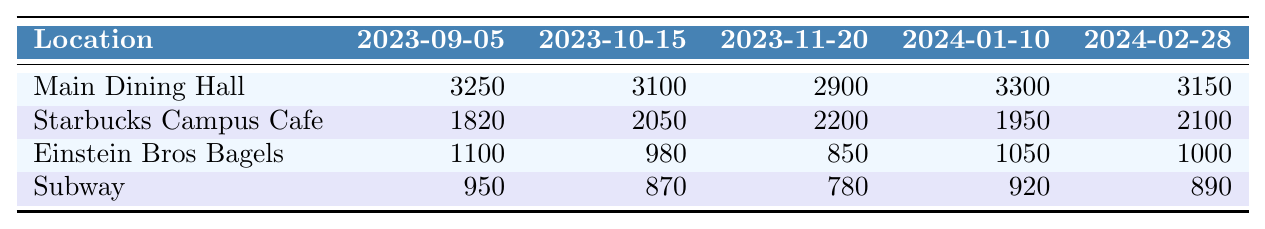What was the foot traffic for Starbucks Campus Cafe on 2023-11-20? The table shows that the foot traffic for Starbucks Campus Cafe on that date is clearly stated as 2200.
Answer: 2200 Which location had the highest foot traffic on 2024-01-10? The values for each location on that date are compared: Main Dining Hall (3300), Starbucks Campus Cafe (1950), Einstein Bros Bagels (1050), and Subway (920). Therefore, Main Dining Hall had the highest traffic.
Answer: Main Dining Hall How much foot traffic did Einstein Bros Bagels receive on 2023-10-15? According to the table, Einstein Bros Bagels had foot traffic of 980 on that date.
Answer: 980 What is the total foot traffic for Main Dining Hall across all listed dates? The foot traffic for Main Dining Hall on each date is summed: 3250 + 3100 + 2900 + 3300 + 3150 = 15700.
Answer: 15700 Did foot traffic for Subway increase from 2023-09-05 to 2023-10-15? The table lists 950 for Subway on 2023-09-05 and 870 on 2023-10-15, showing a decrease.
Answer: No Which eatery had the least foot traffic across all dates considered? By comparing the foot traffic: Subway (950, 870, 780, 920, 890) which totals 4200, Einstein Bros Bagels (1100, 980, 850, 1050, 1000) which totals 4980, and Starbucks Campus Cafe (1820, 2050, 2200, 1950, 2100) totals 11120, it shows Subway has the least total foot traffic.
Answer: Subway What was the average foot traffic for Main Dining Hall over the listed dates? The total traffic for Main Dining Hall is 15700, with 5 data points. To find the average, divide the total by the number of data points: 15700 / 5 = 3140.
Answer: 3140 How did the foot traffic at Starbucks Campus Cafe change from 2023-09-05 to 2024-02-28? The foot traffic was 1820 on 2023-09-05 and increased to 2100 on 2024-02-28. Therefore, it increased by 280.
Answer: Increased Was there ever a day when Subway had more foot traffic than Einstein Bros Bagels? The table shows that Subway's maximum was 950 and all of Einstein Bros Bagels' traffic numbers are higher; hence, Subway never surpassed Einstein Bros Bagels.
Answer: No What was the foot traffic difference for the Main Dining Hall between 2023-11-20 and 2024-01-10? The foot traffic for the Main Dining Hall on 2023-11-20 is 2900 and on 2024-01-10 is 3300. The difference is 3300 - 2900 = 400.
Answer: 400 